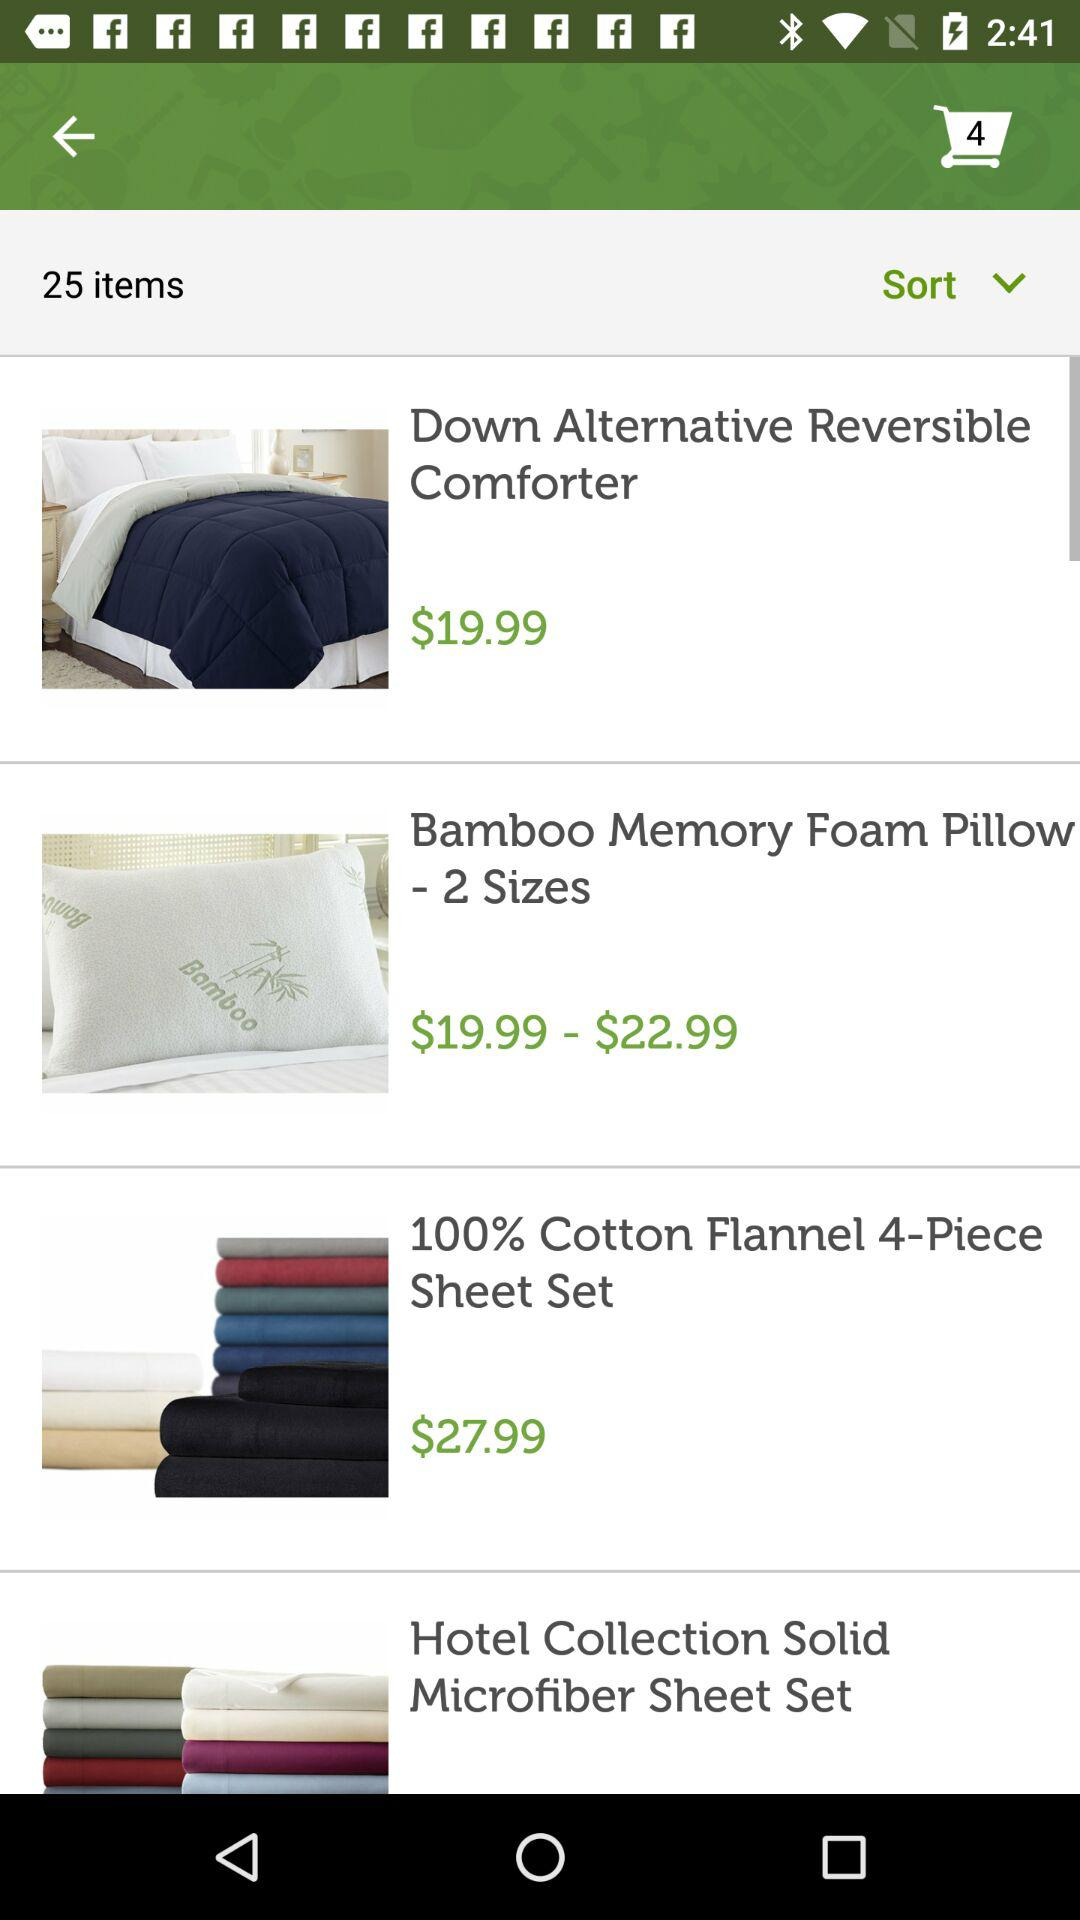How many items are more expensive than $20.00?
Answer the question using a single word or phrase. 2 